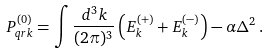<formula> <loc_0><loc_0><loc_500><loc_500>P ^ { ( 0 ) } _ { q r k } = \int \frac { d ^ { 3 } k } { ( 2 \pi ) ^ { 3 } } \left ( E ^ { ( + ) } _ { k } + E ^ { ( - ) } _ { k } \right ) - \alpha \Delta ^ { 2 } \, .</formula> 